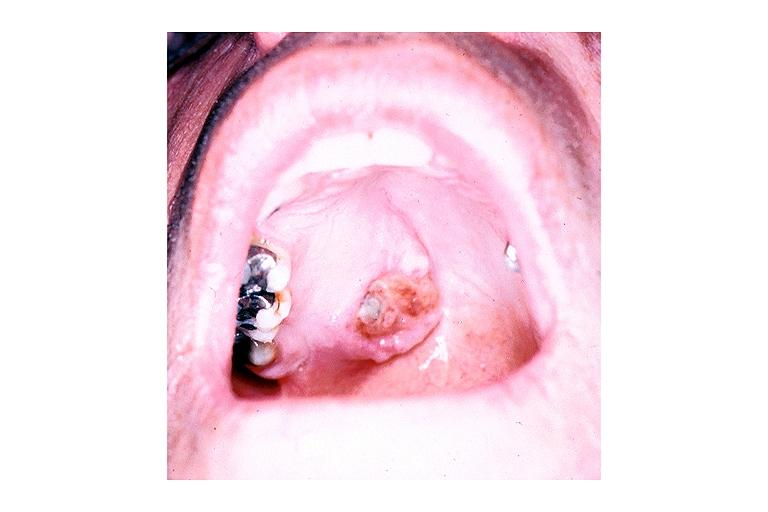does this image show adenoid cystic carcinoma?
Answer the question using a single word or phrase. Yes 